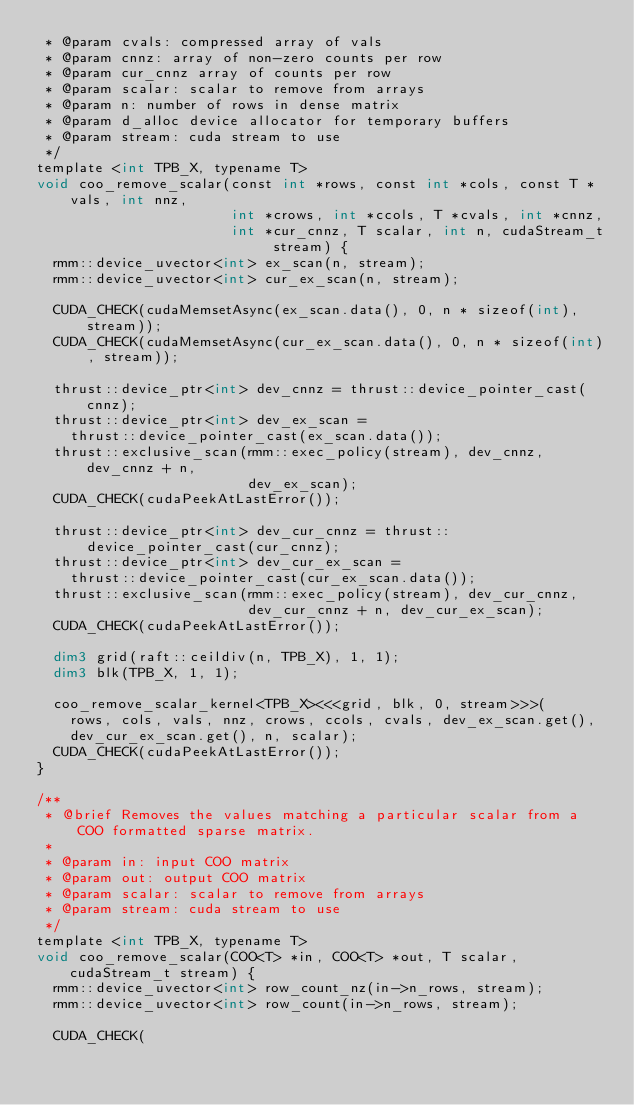Convert code to text. <code><loc_0><loc_0><loc_500><loc_500><_Cuda_> * @param cvals: compressed array of vals
 * @param cnnz: array of non-zero counts per row
 * @param cur_cnnz array of counts per row
 * @param scalar: scalar to remove from arrays
 * @param n: number of rows in dense matrix
 * @param d_alloc device allocator for temporary buffers
 * @param stream: cuda stream to use
 */
template <int TPB_X, typename T>
void coo_remove_scalar(const int *rows, const int *cols, const T *vals, int nnz,
                       int *crows, int *ccols, T *cvals, int *cnnz,
                       int *cur_cnnz, T scalar, int n, cudaStream_t stream) {
  rmm::device_uvector<int> ex_scan(n, stream);
  rmm::device_uvector<int> cur_ex_scan(n, stream);

  CUDA_CHECK(cudaMemsetAsync(ex_scan.data(), 0, n * sizeof(int), stream));
  CUDA_CHECK(cudaMemsetAsync(cur_ex_scan.data(), 0, n * sizeof(int), stream));

  thrust::device_ptr<int> dev_cnnz = thrust::device_pointer_cast(cnnz);
  thrust::device_ptr<int> dev_ex_scan =
    thrust::device_pointer_cast(ex_scan.data());
  thrust::exclusive_scan(rmm::exec_policy(stream), dev_cnnz, dev_cnnz + n,
                         dev_ex_scan);
  CUDA_CHECK(cudaPeekAtLastError());

  thrust::device_ptr<int> dev_cur_cnnz = thrust::device_pointer_cast(cur_cnnz);
  thrust::device_ptr<int> dev_cur_ex_scan =
    thrust::device_pointer_cast(cur_ex_scan.data());
  thrust::exclusive_scan(rmm::exec_policy(stream), dev_cur_cnnz,
                         dev_cur_cnnz + n, dev_cur_ex_scan);
  CUDA_CHECK(cudaPeekAtLastError());

  dim3 grid(raft::ceildiv(n, TPB_X), 1, 1);
  dim3 blk(TPB_X, 1, 1);

  coo_remove_scalar_kernel<TPB_X><<<grid, blk, 0, stream>>>(
    rows, cols, vals, nnz, crows, ccols, cvals, dev_ex_scan.get(),
    dev_cur_ex_scan.get(), n, scalar);
  CUDA_CHECK(cudaPeekAtLastError());
}

/**
 * @brief Removes the values matching a particular scalar from a COO formatted sparse matrix.
 *
 * @param in: input COO matrix
 * @param out: output COO matrix
 * @param scalar: scalar to remove from arrays
 * @param stream: cuda stream to use
 */
template <int TPB_X, typename T>
void coo_remove_scalar(COO<T> *in, COO<T> *out, T scalar, cudaStream_t stream) {
  rmm::device_uvector<int> row_count_nz(in->n_rows, stream);
  rmm::device_uvector<int> row_count(in->n_rows, stream);

  CUDA_CHECK(</code> 